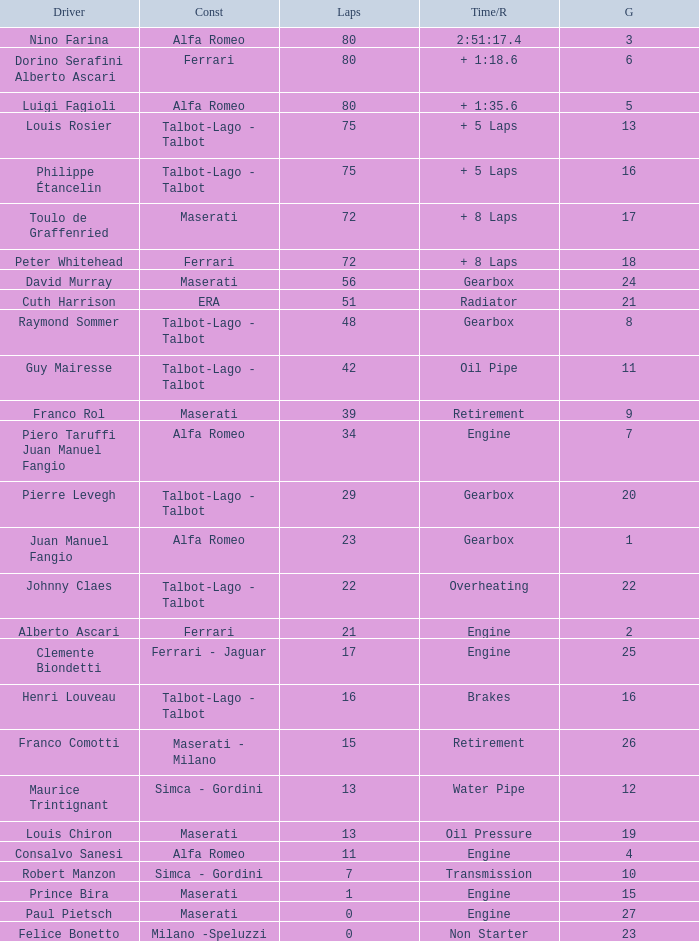When grid is less than 7, laps are greater than 17, and time/retired is + 1:35.6, who is the constructor? Alfa Romeo. 